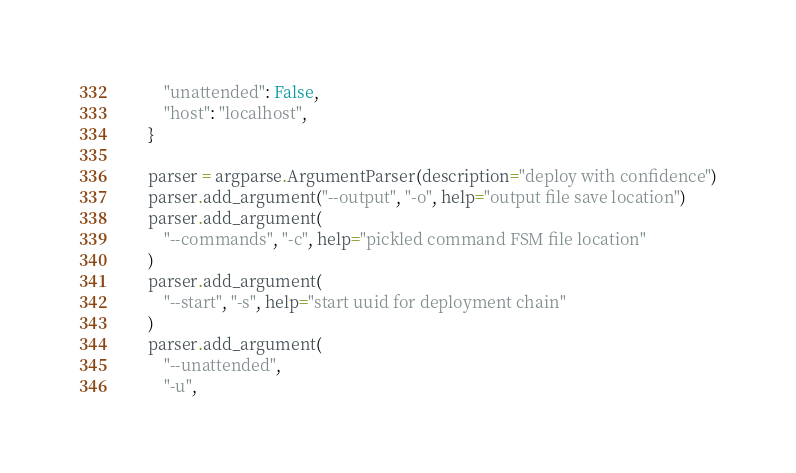<code> <loc_0><loc_0><loc_500><loc_500><_Python_>        "unattended": False,
        "host": "localhost",
    }

    parser = argparse.ArgumentParser(description="deploy with confidence")
    parser.add_argument("--output", "-o", help="output file save location")
    parser.add_argument(
        "--commands", "-c", help="pickled command FSM file location"
    )
    parser.add_argument(
        "--start", "-s", help="start uuid for deployment chain"
    )
    parser.add_argument(
        "--unattended",
        "-u",</code> 